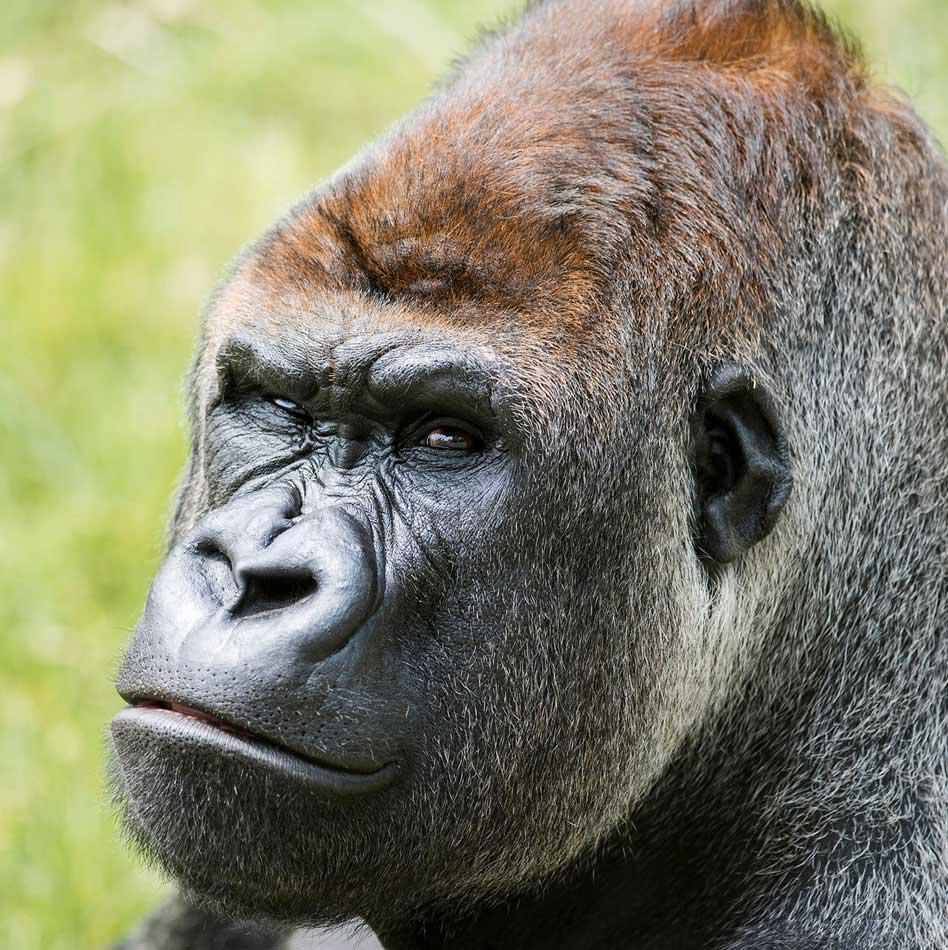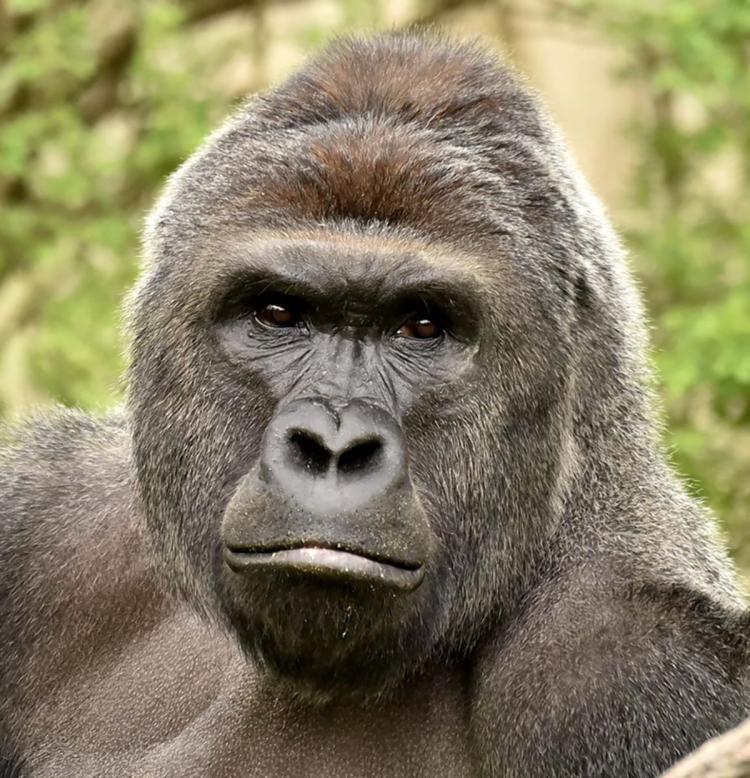The first image is the image on the left, the second image is the image on the right. For the images displayed, is the sentence "One image includes a silverback gorilla on all fours, and the other shows a silverback gorilla sitting on green grass." factually correct? Answer yes or no. No. The first image is the image on the left, the second image is the image on the right. Given the left and right images, does the statement "The gorilla in the right image is sitting in the grass near a bunch of weeds." hold true? Answer yes or no. No. 